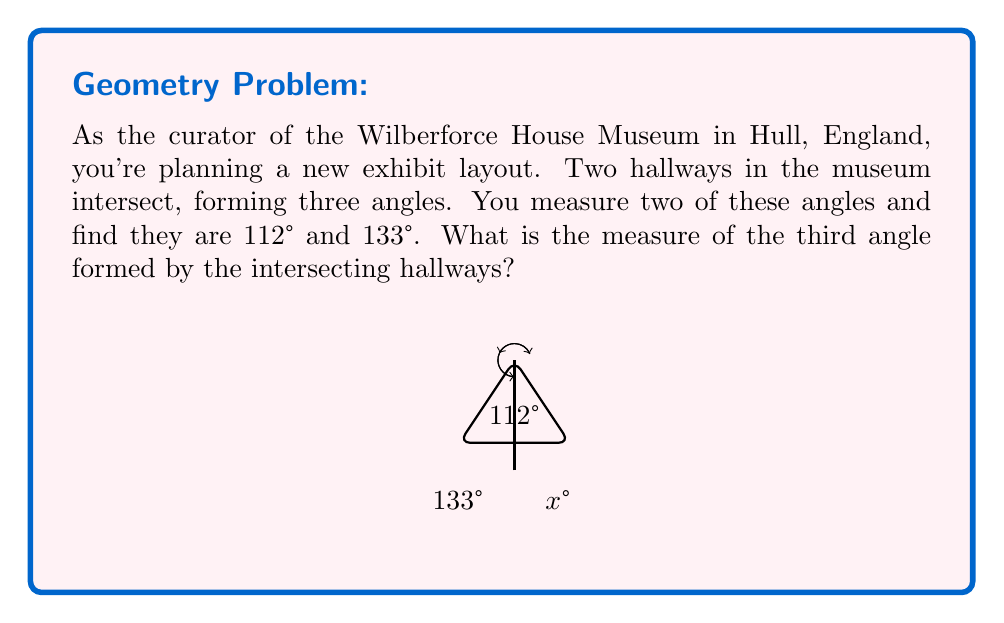Could you help me with this problem? Let's approach this step-by-step:

1) First, recall that when two straight lines intersect, they form four angles. The sum of these four angles is always 360°.

2) In this case, we're given two of the angles and asked to find the third. Let's call the unknown angle $x°$.

3) We know that one of the four angles is the sum of the two given angles:
   $112° + 133° = 245°$

4) This means that the remaining two angles (one of which is our unknown $x°$) must sum to:
   $360° - 245° = 115°$

5) We can express this as an equation:
   $x° + 115° = 360°$

6) Solving for $x$:
   $x° = 360° - 115° = 245°$

7) However, remember that we're looking for the third angle, not the fourth. The third angle is the complement of $x°$ to 115°.

8) Therefore, the third angle measure is:
   $115° - x° = 115° - 245° = -130°$

9) Since angle measures are always positive, we take the absolute value:
   $|-130°| = 130°$

Thus, the measure of the third angle is 130°.
Answer: 130° 